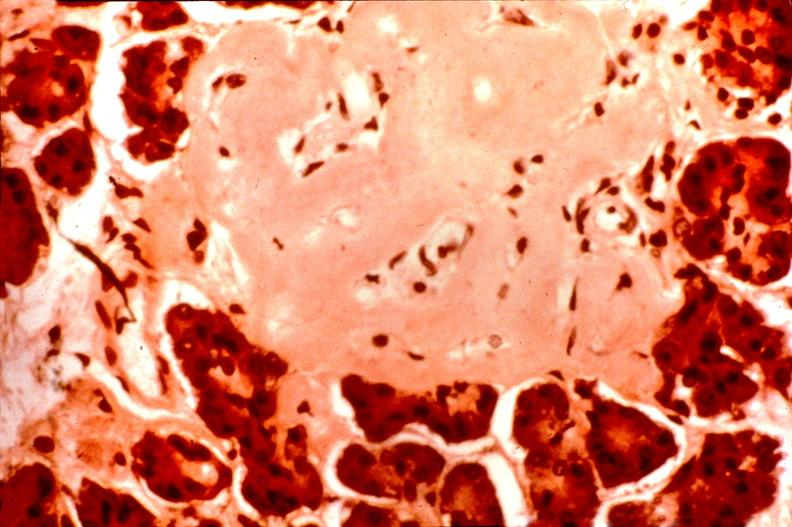s fibrinous peritonitis present?
Answer the question using a single word or phrase. No 